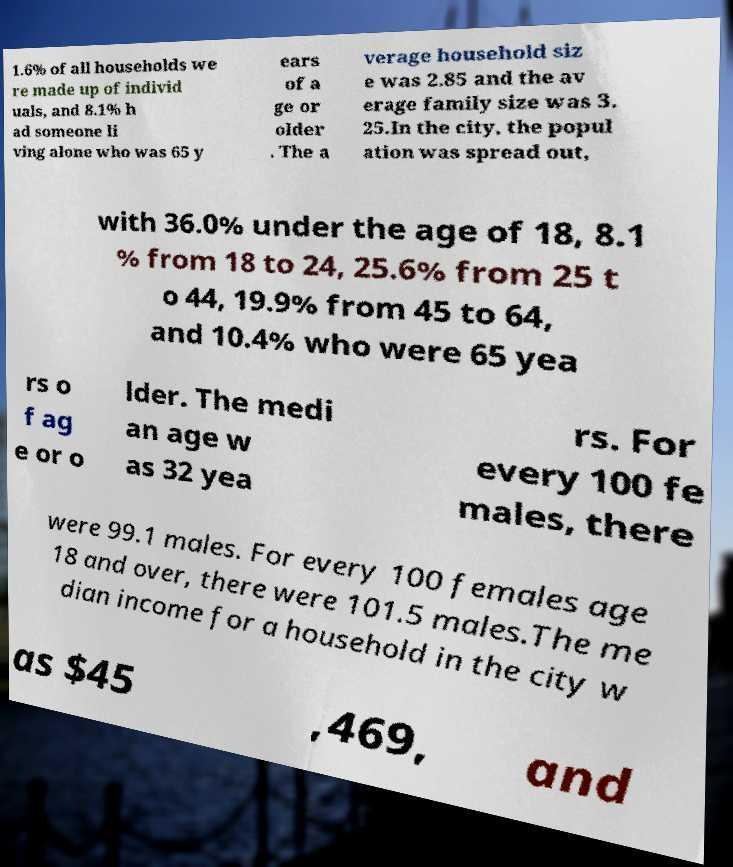Could you extract and type out the text from this image? 1.6% of all households we re made up of individ uals, and 8.1% h ad someone li ving alone who was 65 y ears of a ge or older . The a verage household siz e was 2.85 and the av erage family size was 3. 25.In the city, the popul ation was spread out, with 36.0% under the age of 18, 8.1 % from 18 to 24, 25.6% from 25 t o 44, 19.9% from 45 to 64, and 10.4% who were 65 yea rs o f ag e or o lder. The medi an age w as 32 yea rs. For every 100 fe males, there were 99.1 males. For every 100 females age 18 and over, there were 101.5 males.The me dian income for a household in the city w as $45 ,469, and 